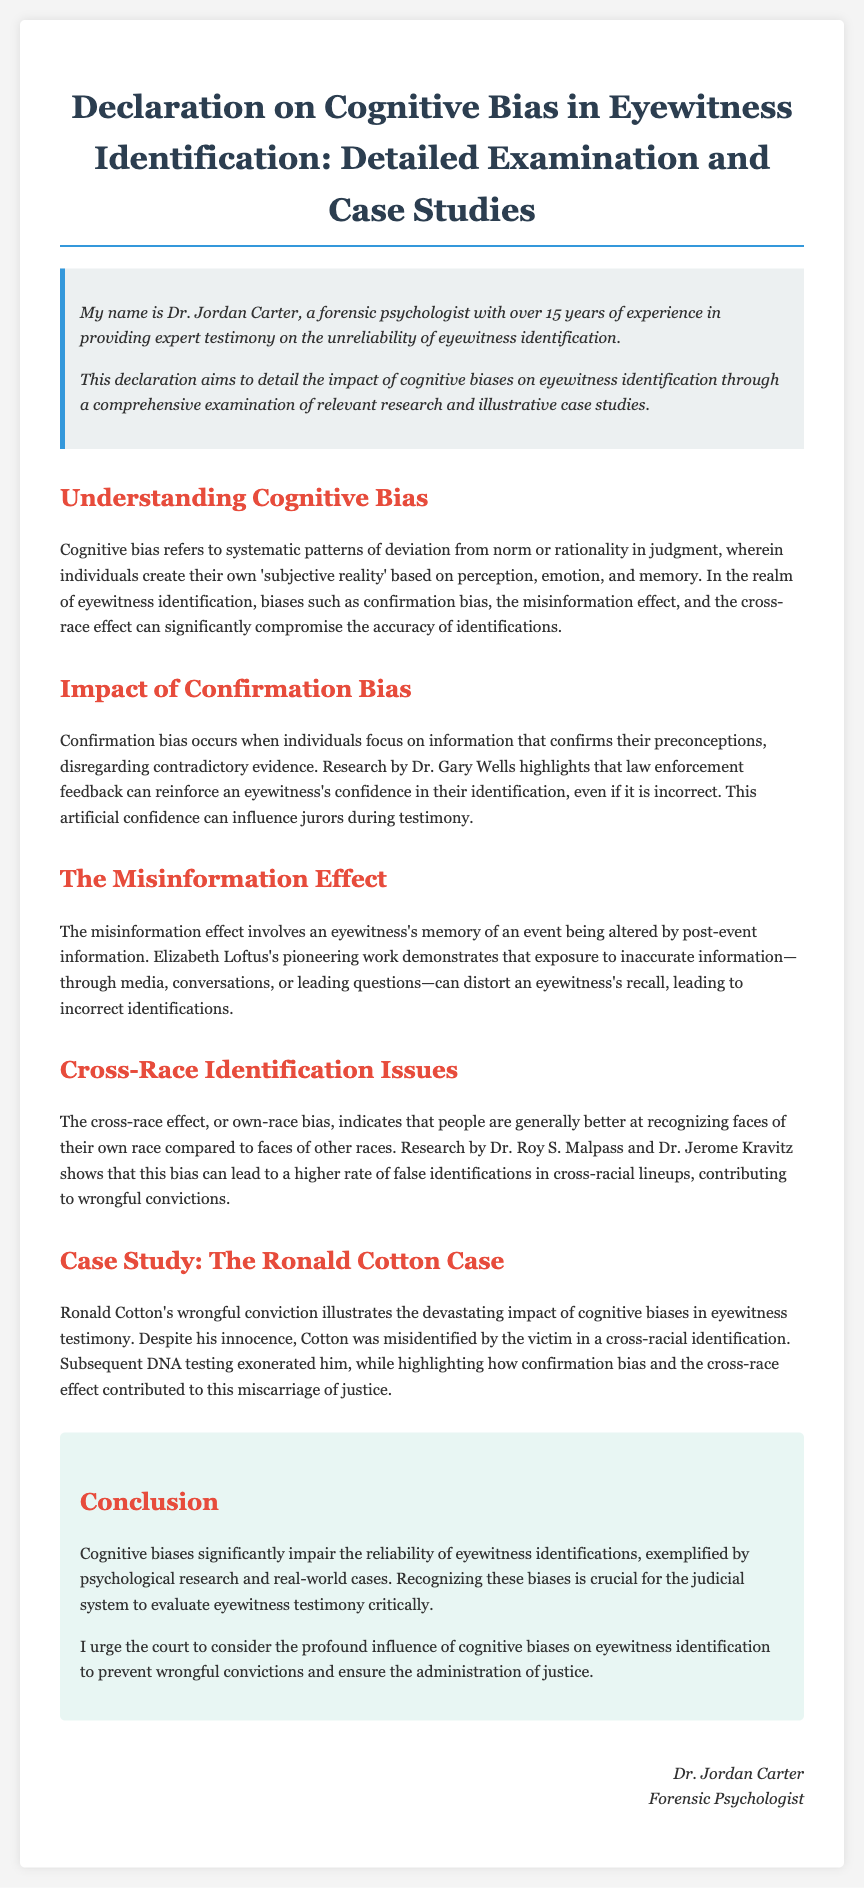What is the name of the forensic psychologist? The document states the name of the forensic psychologist as "Dr. Jordan Carter."
Answer: Dr. Jordan Carter How many years of experience does Dr. Jordan Carter have? The declaration mentions that Dr. Jordan Carter has over 15 years of experience.
Answer: 15 years What is the topic of the declaration? The title of the document specifies the topic as "Cognitive Bias in Eyewitness Identification."
Answer: Cognitive Bias in Eyewitness Identification What researcher's work highlights the impact of confirmation bias? The declaration references Dr. Gary Wells' research in relation to confirmation bias.
Answer: Dr. Gary Wells What type of bias leads to higher rates of false identifications in cross-racial lineups? The document mentions the "cross-race effect" as the bias contributing to this issue.
Answer: Cross-race effect In the case study, who was wrongfully convicted? The document identifies "Ronald Cotton" as the individual who was wrongfully convicted.
Answer: Ronald Cotton Which researcher’s work is notable for the misinformation effect? The declaration highlights Elizabeth Loftus's pioneering work regarding the misinformation effect.
Answer: Elizabeth Loftus What does the conclusion emphasize regarding eyewitness identifications? The conclusion stresses the impact of cognitive biases on the reliability of eyewitness identifications.
Answer: Impact of cognitive biases 